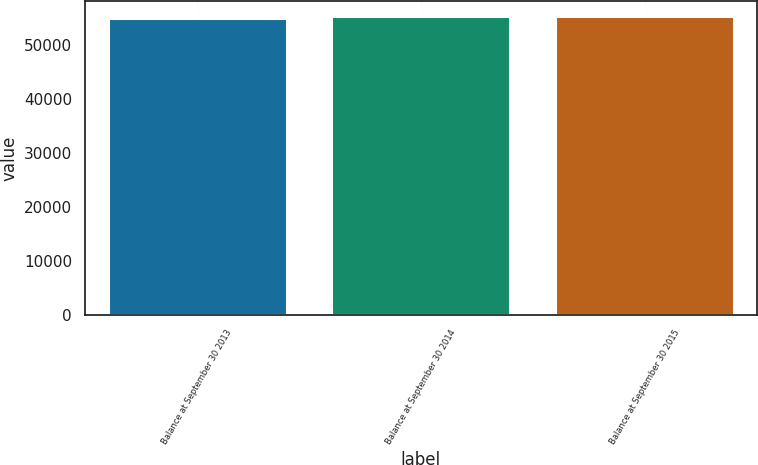Convert chart to OTSL. <chart><loc_0><loc_0><loc_500><loc_500><bar_chart><fcel>Balance at September 30 2013<fcel>Balance at September 30 2014<fcel>Balance at September 30 2015<nl><fcel>55080<fcel>55369<fcel>55397.9<nl></chart> 